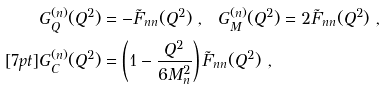<formula> <loc_0><loc_0><loc_500><loc_500>& G _ { Q } ^ { ( n ) } ( Q ^ { 2 } ) = - \tilde { F } _ { n n } ( Q ^ { 2 } ) \ , \ \ G _ { M } ^ { ( n ) } ( Q ^ { 2 } ) = 2 \tilde { F } _ { n n } ( Q ^ { 2 } ) \ , \\ [ 7 p t ] & G _ { C } ^ { ( n ) } ( Q ^ { 2 } ) = \left ( 1 - \frac { Q ^ { 2 } } { 6 M ^ { 2 } _ { n } } \right ) \tilde { F } _ { n n } ( Q ^ { 2 } ) \ ,</formula> 